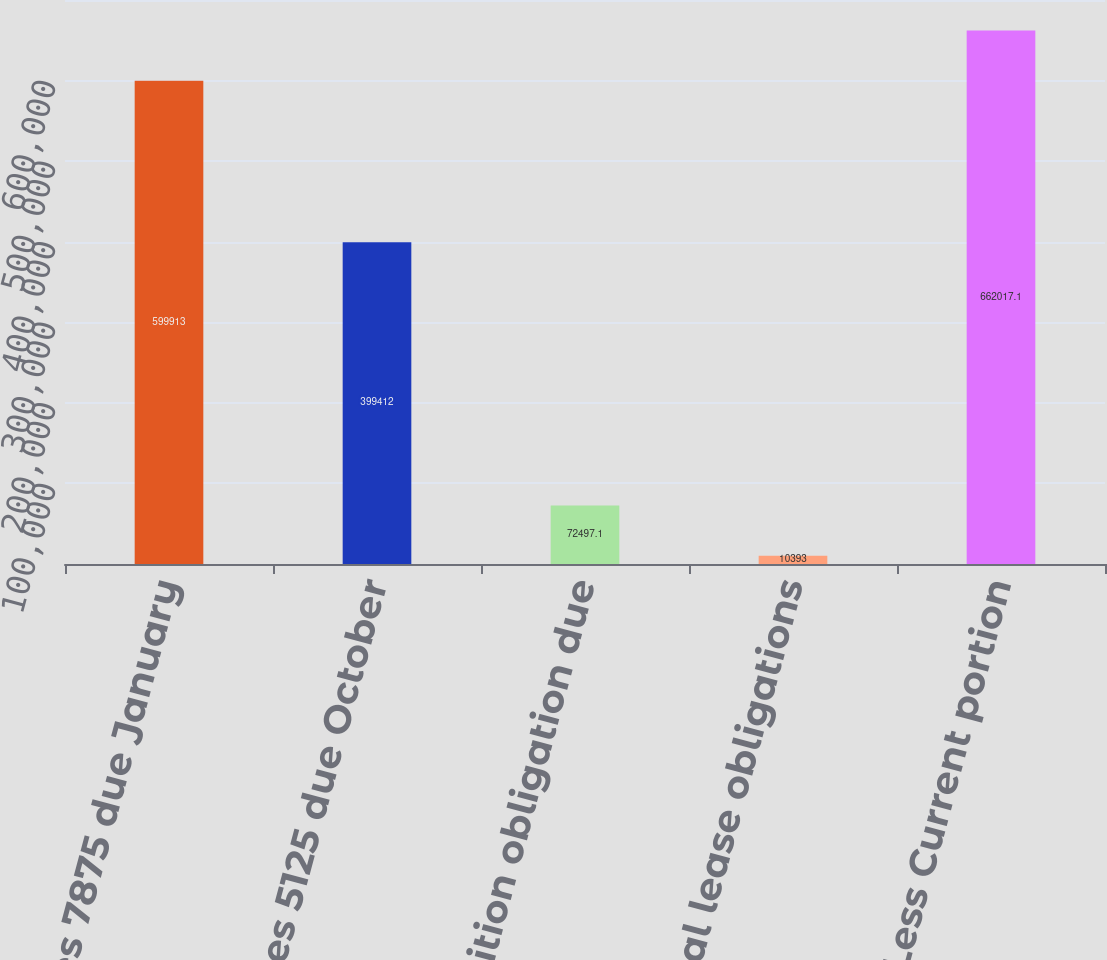Convert chart to OTSL. <chart><loc_0><loc_0><loc_500><loc_500><bar_chart><fcel>Senior Notes 7875 due January<fcel>Senior Notes 5125 due October<fcel>Acquisition obligation due<fcel>Capital lease obligations<fcel>Less Current portion<nl><fcel>599913<fcel>399412<fcel>72497.1<fcel>10393<fcel>662017<nl></chart> 